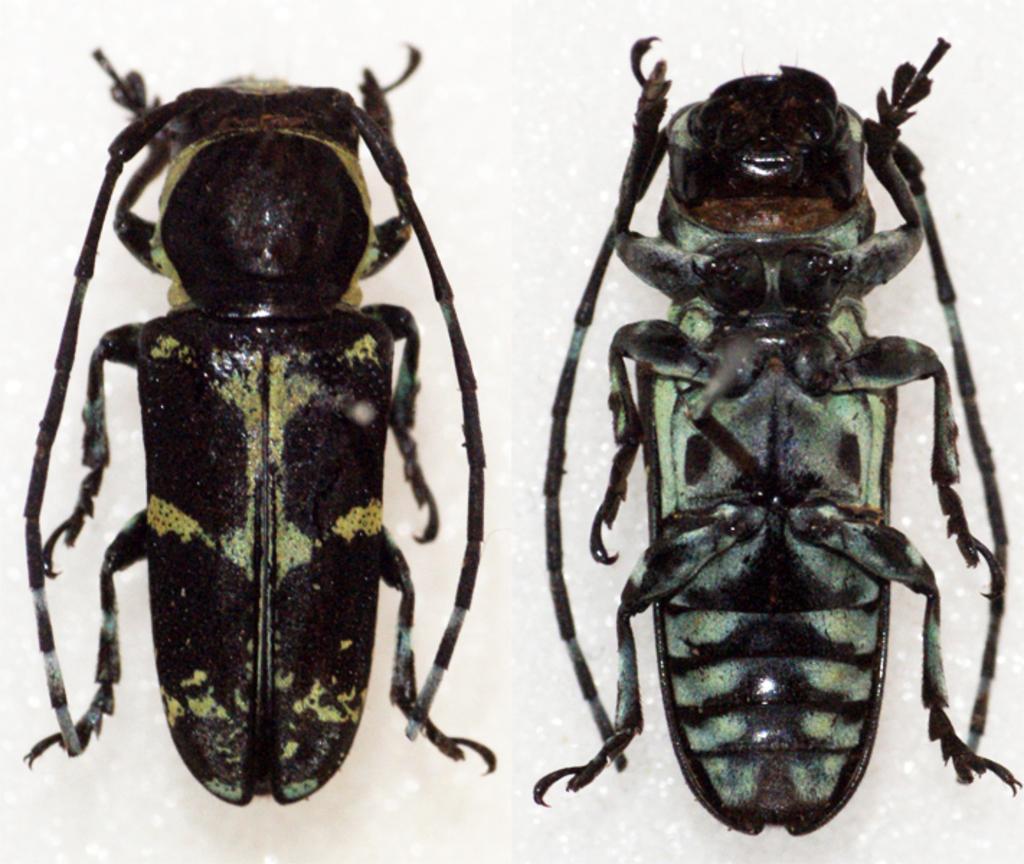Can you describe this image briefly? In this image I can see two insects which are of black and green colour. I can also see white colour in background. 